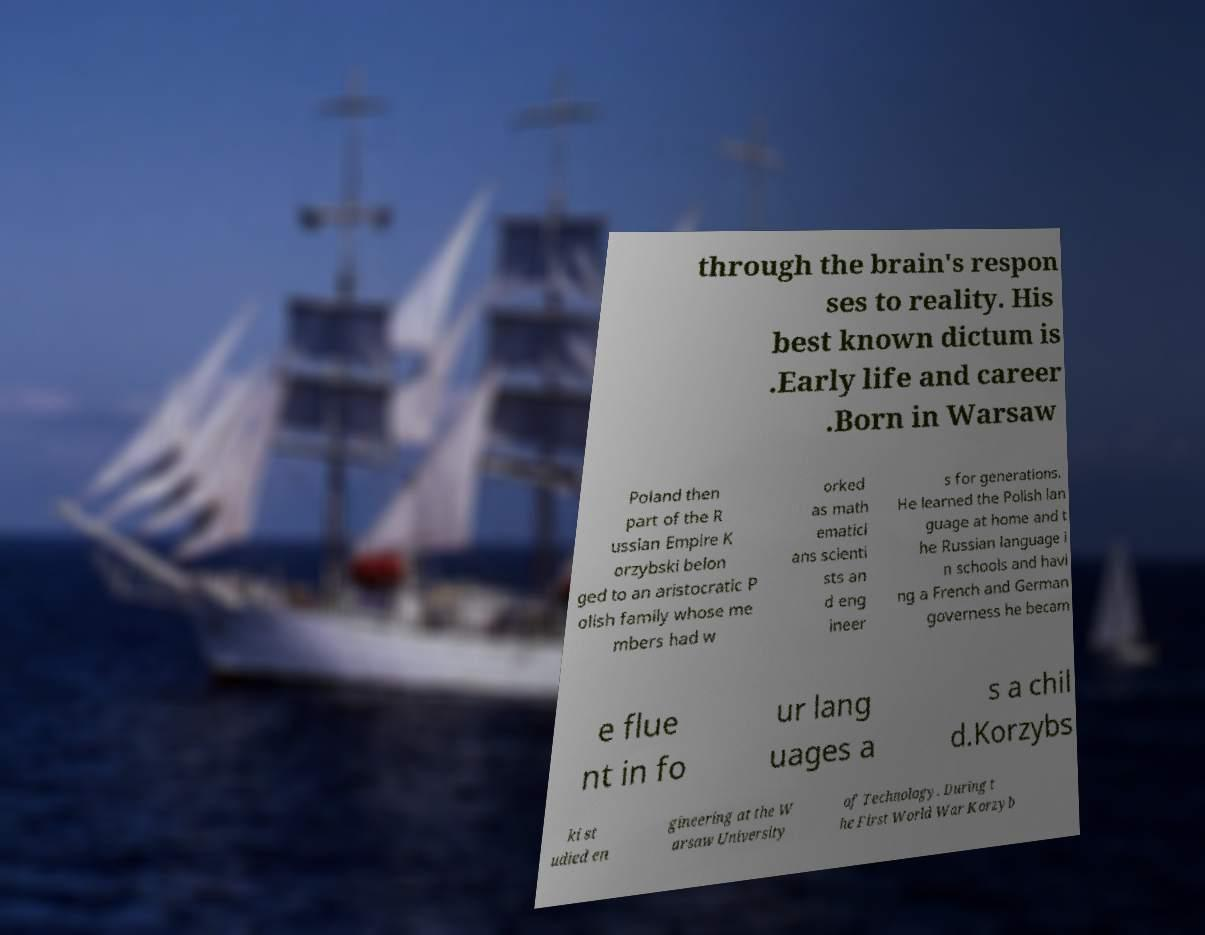There's text embedded in this image that I need extracted. Can you transcribe it verbatim? through the brain's respon ses to reality. His best known dictum is .Early life and career .Born in Warsaw Poland then part of the R ussian Empire K orzybski belon ged to an aristocratic P olish family whose me mbers had w orked as math ematici ans scienti sts an d eng ineer s for generations. He learned the Polish lan guage at home and t he Russian language i n schools and havi ng a French and German governess he becam e flue nt in fo ur lang uages a s a chil d.Korzybs ki st udied en gineering at the W arsaw University of Technology. During t he First World War Korzyb 